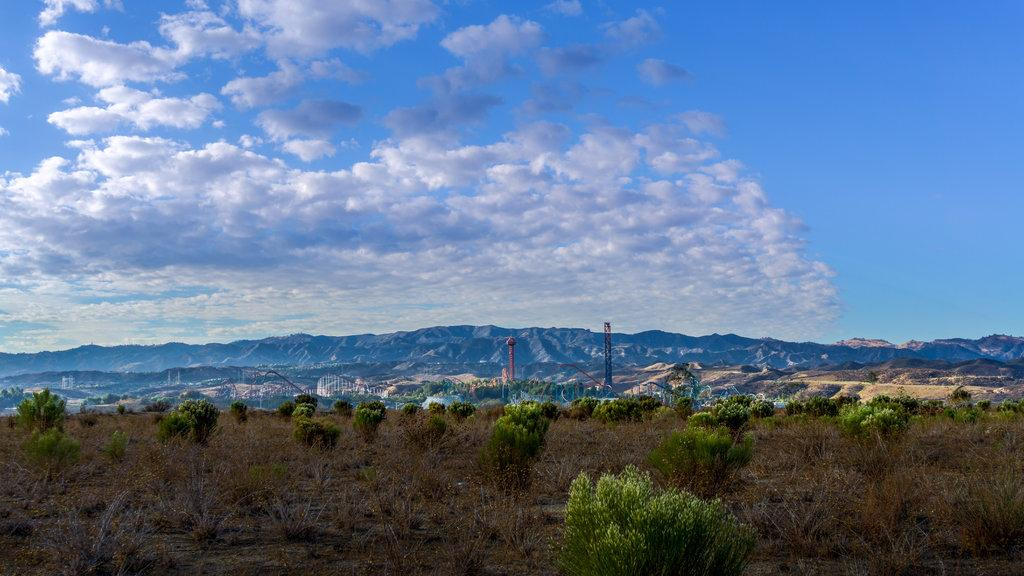What type of natural elements can be seen in the image? There are trees and mountains in the image. What man-made structures are present in the image? There is a fence, a pole, and a tower in the image. What is visible in the background of the image? The sky is visible in the background of the image. What type of invention is being demonstrated in the image? There is no invention being demonstrated in the image; it features trees, mountains, a fence, a pole, a tower, and the sky. Can you tell me how many carriages are present in the image? There are no carriages present in the image. 